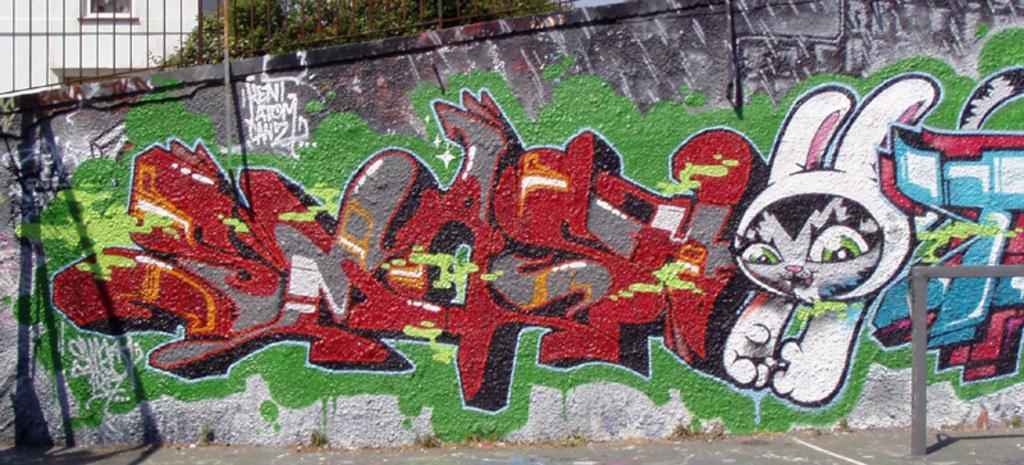Can you describe this image briefly? In the foreground of this image, there is a wall with graffiti painting on it. On the right side of the image, there is a rod and on the top of the image, we can see trees, railing and the building. 